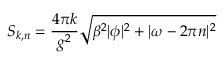<formula> <loc_0><loc_0><loc_500><loc_500>S _ { k , n } = \frac { 4 \pi k } { g ^ { 2 } } \sqrt { \beta ^ { 2 } | \phi | ^ { 2 } + | \omega - 2 \pi n | ^ { 2 } }</formula> 